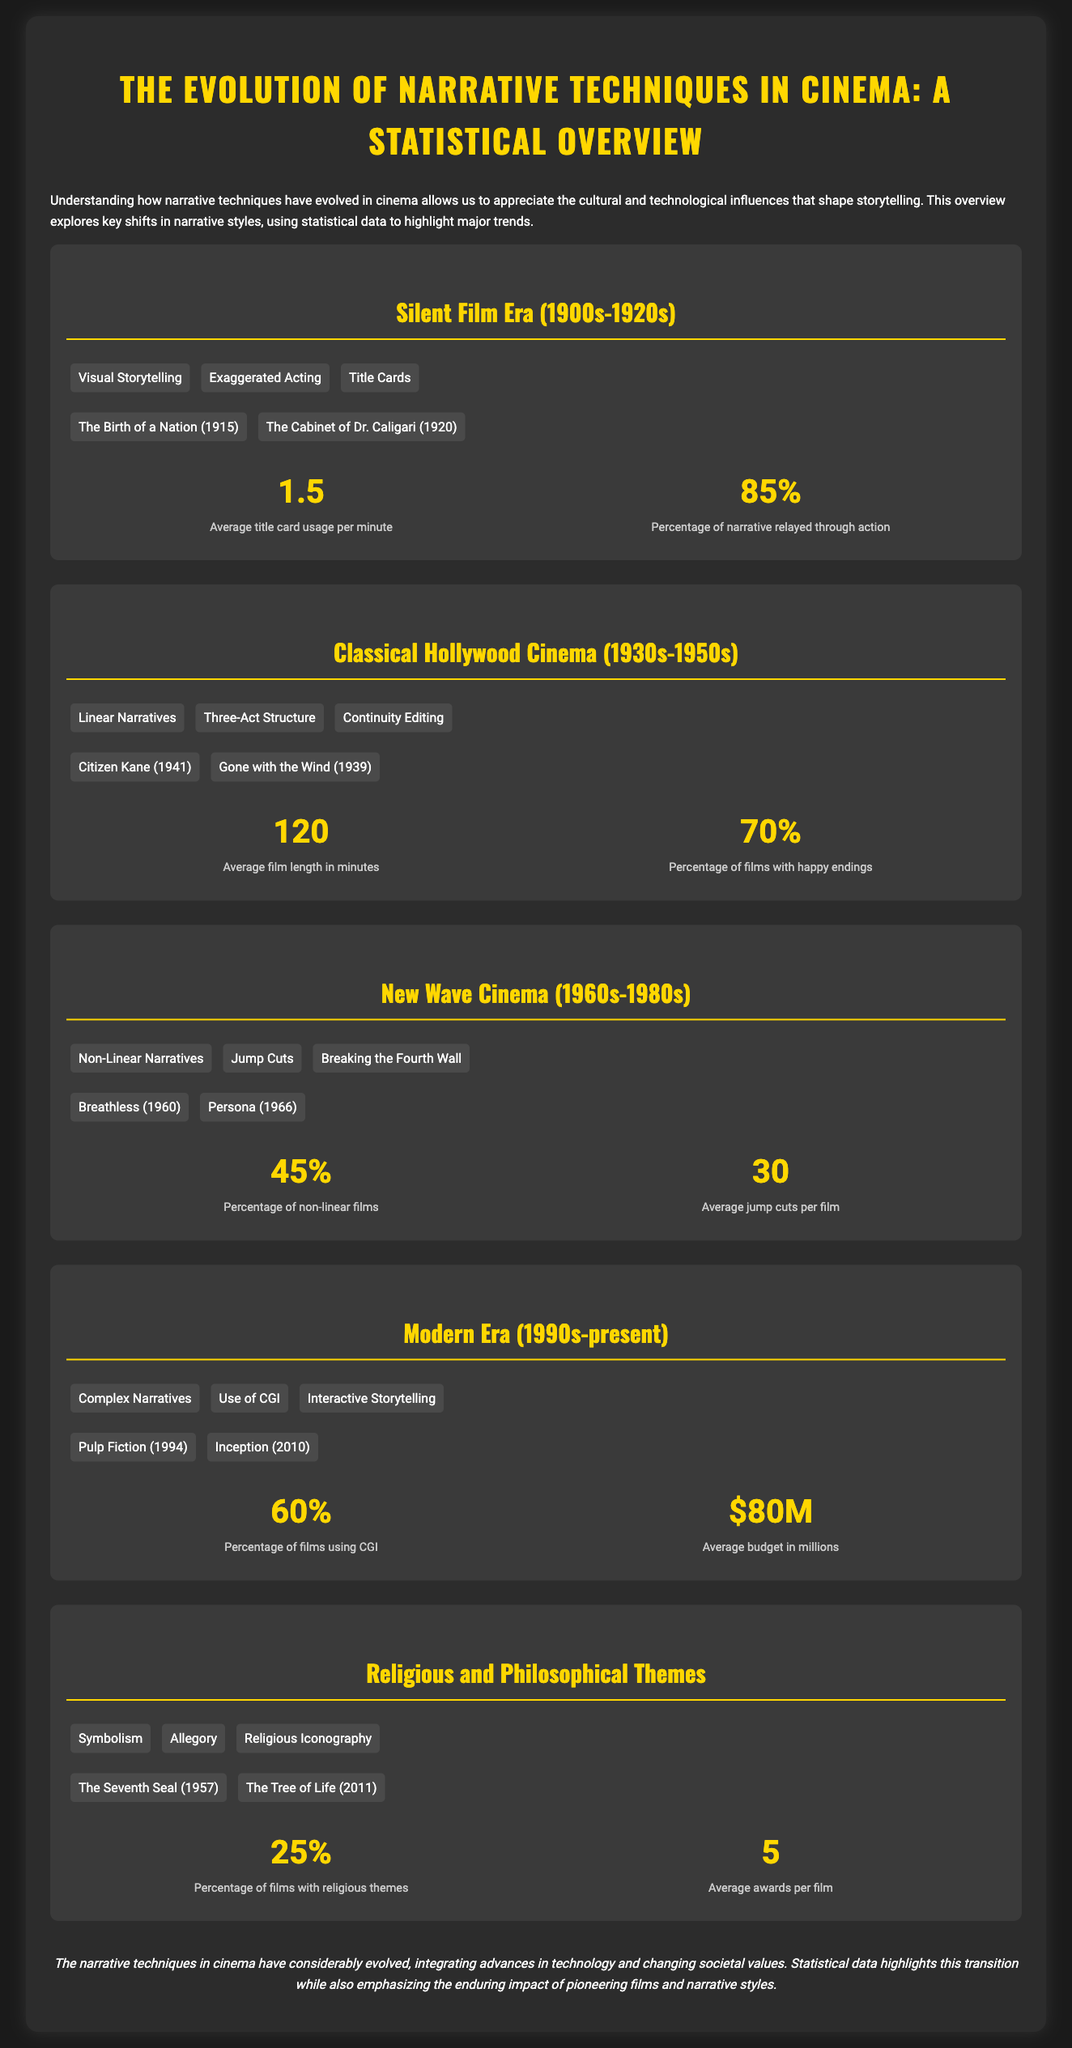What are the three key techniques of the Silent Film Era? The techniques listed for the Silent Film Era are Visual Storytelling, Exaggerated Acting, and Title Cards.
Answer: Visual Storytelling, Exaggerated Acting, Title Cards What is the percentage of films with happy endings in Classical Hollywood Cinema? The document states that 70% of films from this era have happy endings.
Answer: 70% Which two films represent the New Wave Cinema era? The films highlighted for the New Wave Cinema era are Breathless and Persona.
Answer: Breathless, Persona What was the average budget in millions during the Modern Era? The average budget for films in the Modern Era is reported as $80M.
Answer: $80M What percentage of films include religious themes? According to the document, 25% of films feature religious themes.
Answer: 25% What narrative technique is associated with the Modern Era? One of the techniques mentioned for the Modern Era is Interactive Storytelling.
Answer: Interactive Storytelling How many average awards do films with religious themes receive? The document states that films with religious themes have an average of 5 awards.
Answer: 5 What was the average film length during Classical Hollywood Cinema? The average length of films in this era is indicated as 120 minutes.
Answer: 120 What percentage of non-linear films is noted in the New Wave Cinema era? The document indicates that 45% of films from the New Wave Cinema era are non-linear.
Answer: 45% 